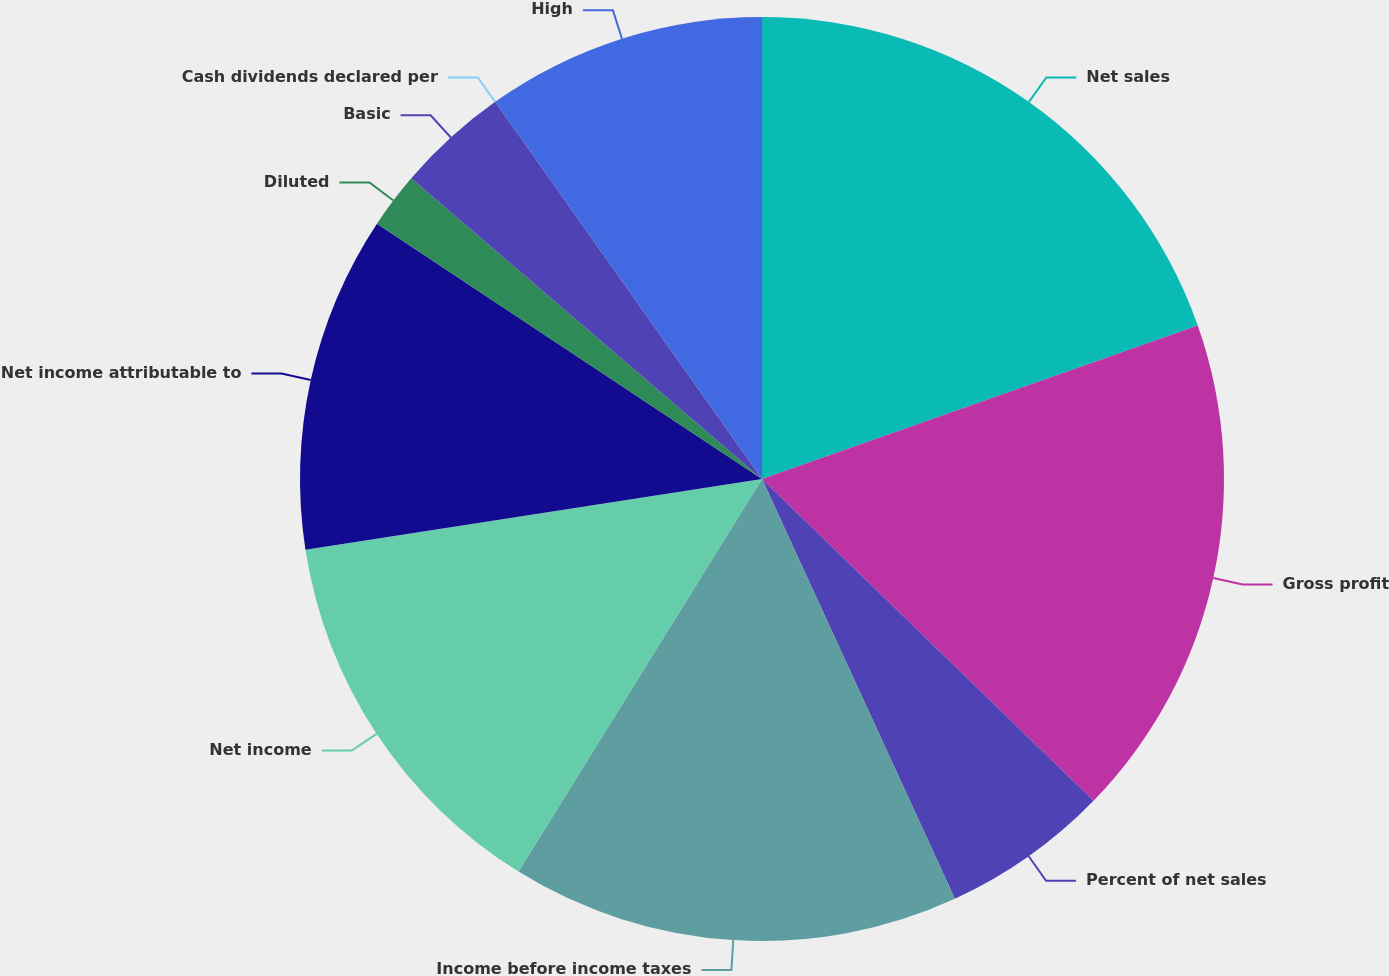Convert chart to OTSL. <chart><loc_0><loc_0><loc_500><loc_500><pie_chart><fcel>Net sales<fcel>Gross profit<fcel>Percent of net sales<fcel>Income before income taxes<fcel>Net income<fcel>Net income attributable to<fcel>Diluted<fcel>Basic<fcel>Cash dividends declared per<fcel>High<nl><fcel>19.61%<fcel>17.65%<fcel>5.88%<fcel>15.69%<fcel>13.72%<fcel>11.76%<fcel>1.96%<fcel>3.92%<fcel>0.0%<fcel>9.8%<nl></chart> 